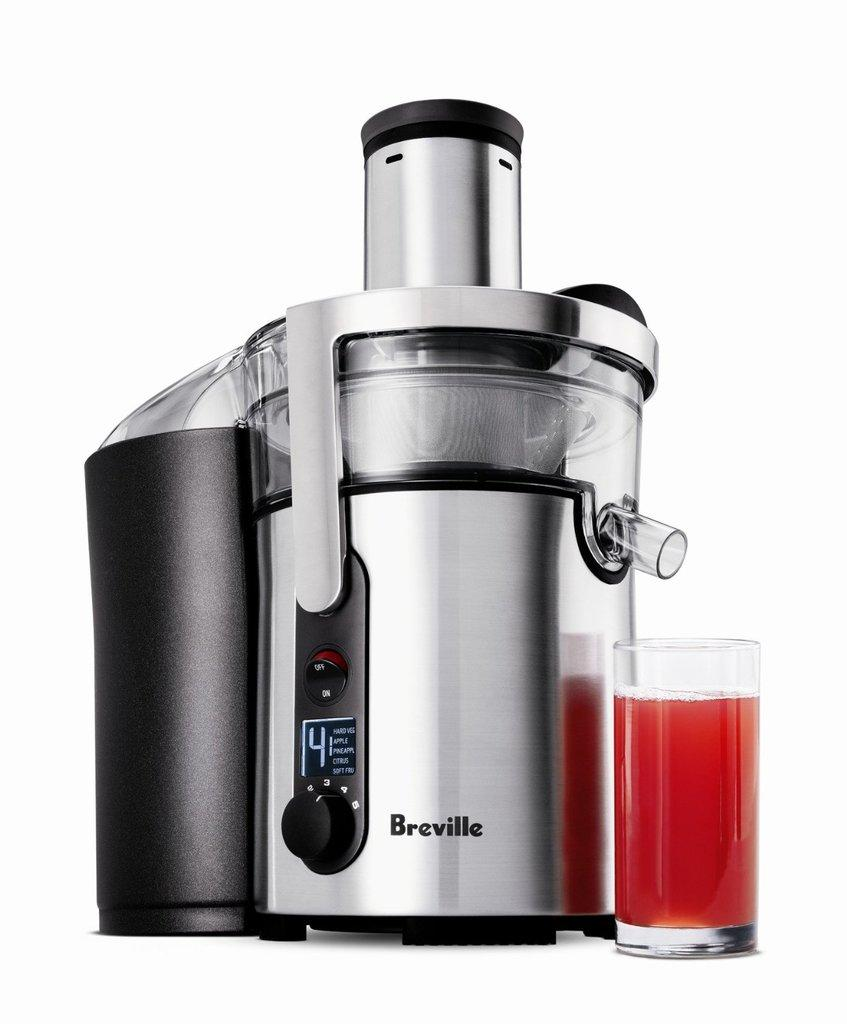<image>
Present a compact description of the photo's key features. the word Breville is on the silver item 